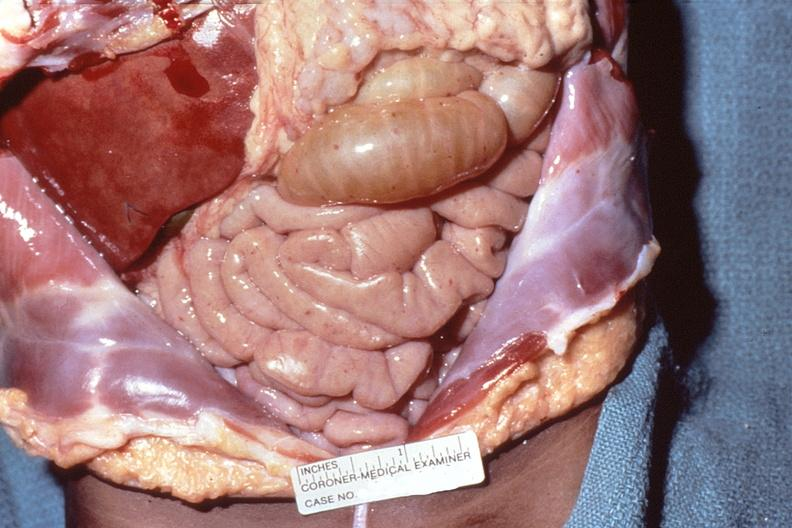where is this area in the body?
Answer the question using a single word or phrase. Abdomen 